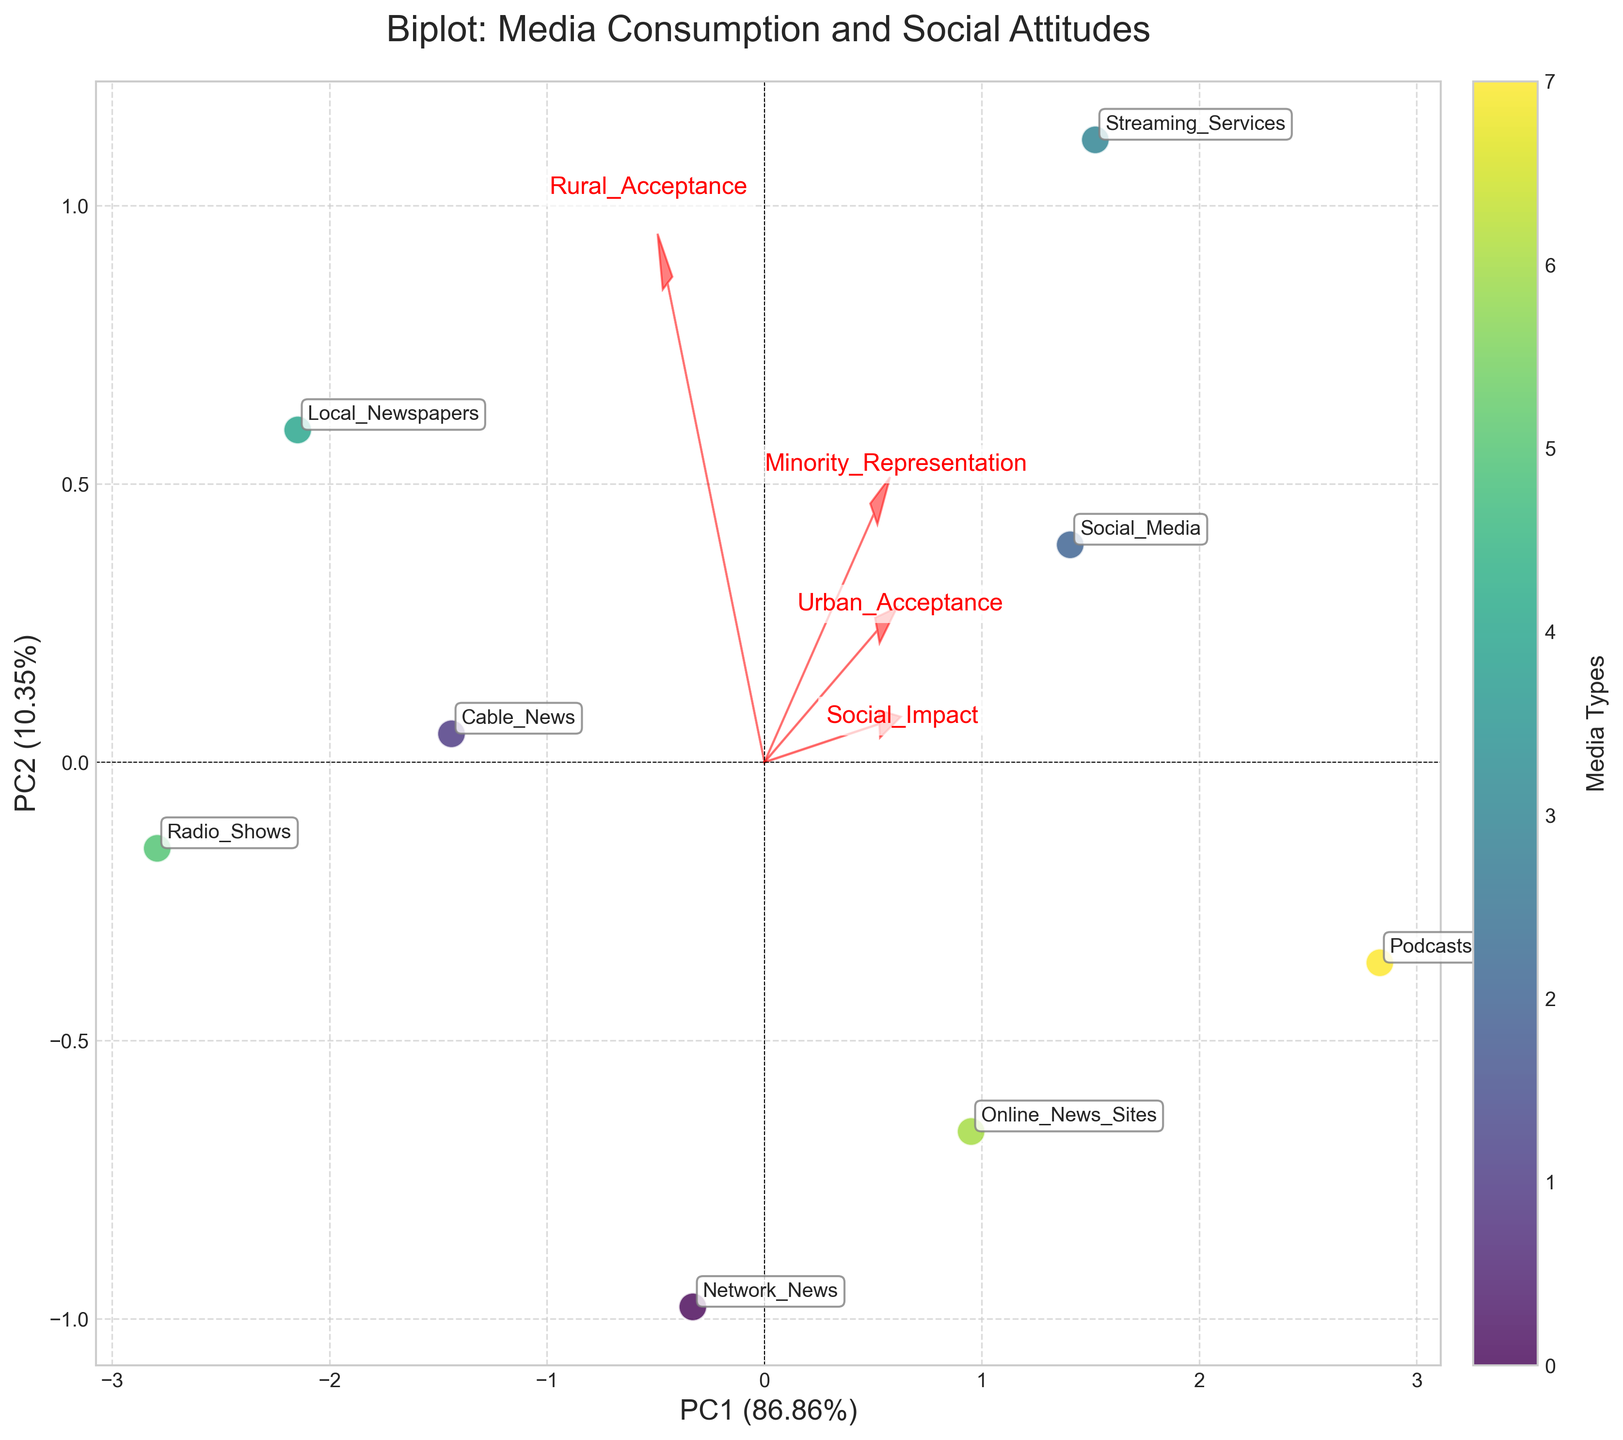What's the title of the biplot? Look at the top of the figure where the title is usually located.
Answer: Biplot: Media Consumption and Social Attitudes How many data points are shown in the biplot? Count the number of unique media types labeled on the plot.
Answer: 8 Which media type has the highest PC1 value? Find the media type furthest to the right along the PC1 axis.
Answer: Podcasts What feature vector is most aligned with PC2? Observe which feature vector arrow points most directly upwards along the PC2 axis.
Answer: Urban_Acceptance How does the representation of Online News Sites compare between urban and rural areas? Compare the positions of the corresponding arrows for Online News Sites along the Urban_Acceptance and Rural_Acceptance vectors.
Answer: Higher in urban areas Which media type is closest to Social Media in terms of PC1 and PC2 values? Look at the proximity of points labeled "Social Media" and find the closest neighboring point.
Answer: Streaming Services Are Local Newspapers more associated with Urban_Acceptance or Rural_Acceptance? Compare the direction and length of the arrows that point toward the Local Newspapers point.
Answer: Rural_Acceptance What's the approximate PC1 variance explained by the first principal component? Check the label of the x-axis which mentions the variance explained in percentage.
Answer: ~54.2% How do Streaming Services and Radio Shows compare in terms of Minority Representation? Observe the positions of these points relative to the Minority_Representation vector direction.
Answer: Streaming Services have higher Minority Representation Which feature vector is least aligned with PC1? Identify the feature vector arrow that points closest to the vertical or along the PC2 axis.
Answer: Urban_Acceptance 